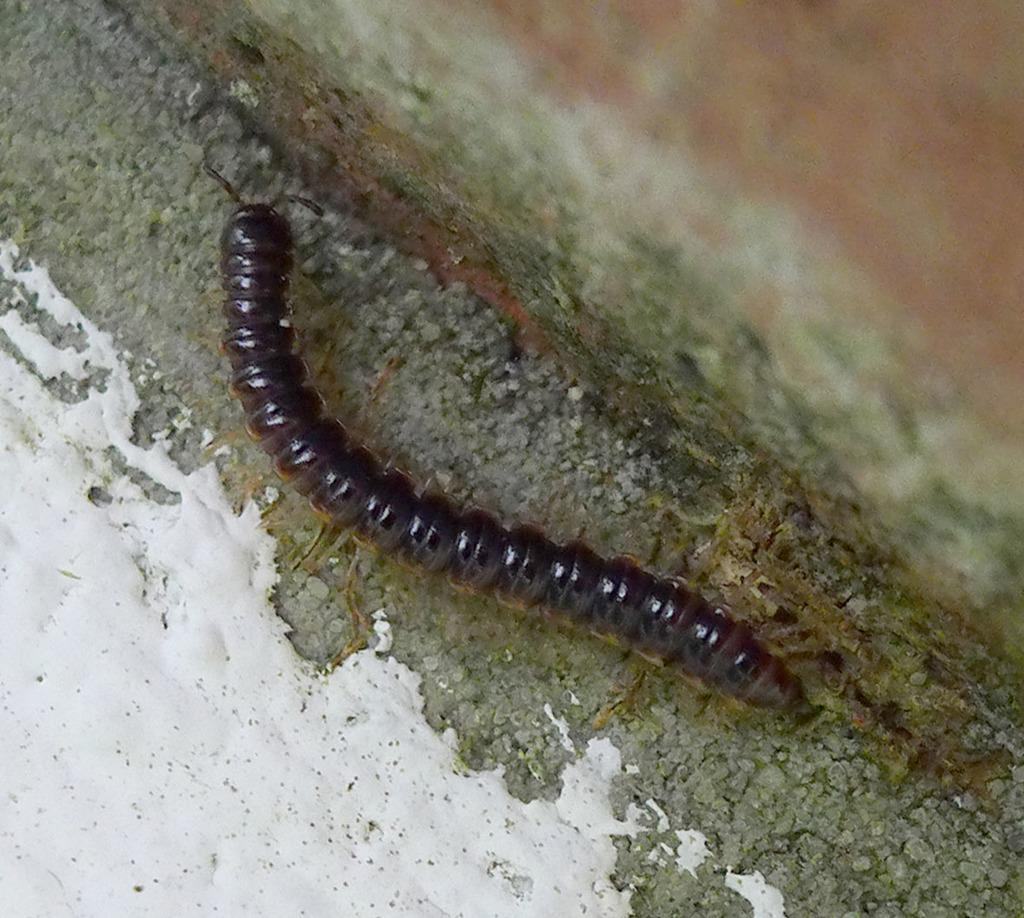What type of creature can be seen in the image? There is an insect in the image. What can be seen in the background of the image? There is a wall visible in the background of the image. What type of berry is being eaten by the giants in the image? There are no giants or berries present in the image; it features an insect and a wall. 